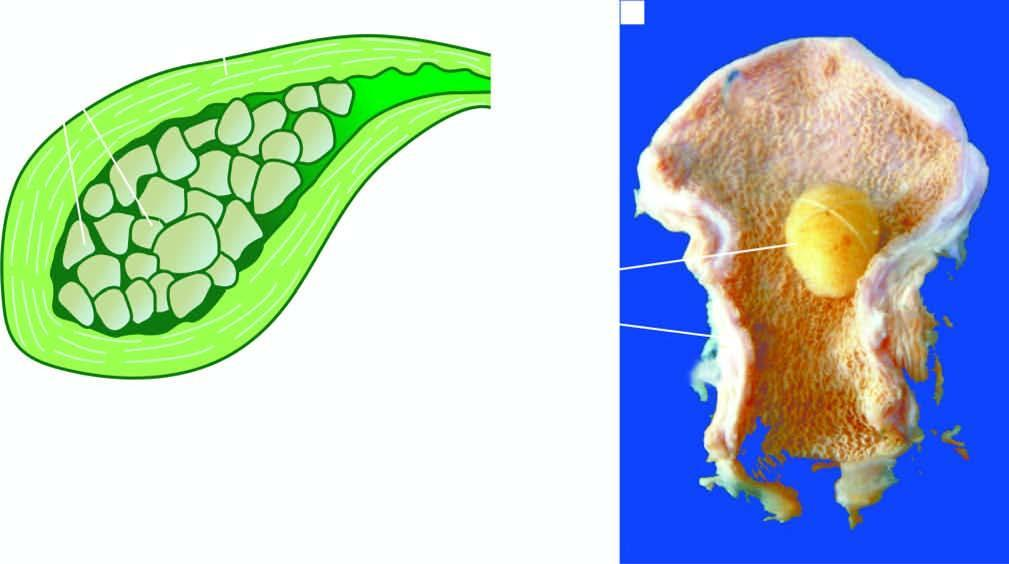does the nuclei of affected tubules contain a single, large, oval, and hard yellow-white gallstone?
Answer the question using a single word or phrase. No 